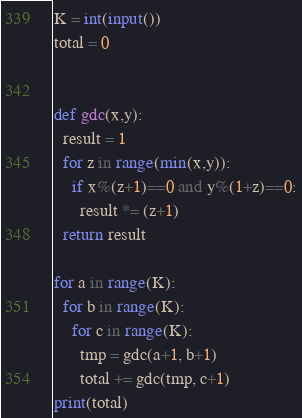<code> <loc_0><loc_0><loc_500><loc_500><_Python_>K = int(input())
total = 0


def gdc(x,y):
  result = 1
  for z in range(min(x,y)):
    if x%(z+1)==0 and y%(1+z)==0:
      result *= (z+1)
  return result

for a in range(K):
  for b in range(K):
    for c in range(K):
      tmp = gdc(a+1, b+1)
      total += gdc(tmp, c+1)
print(total)</code> 